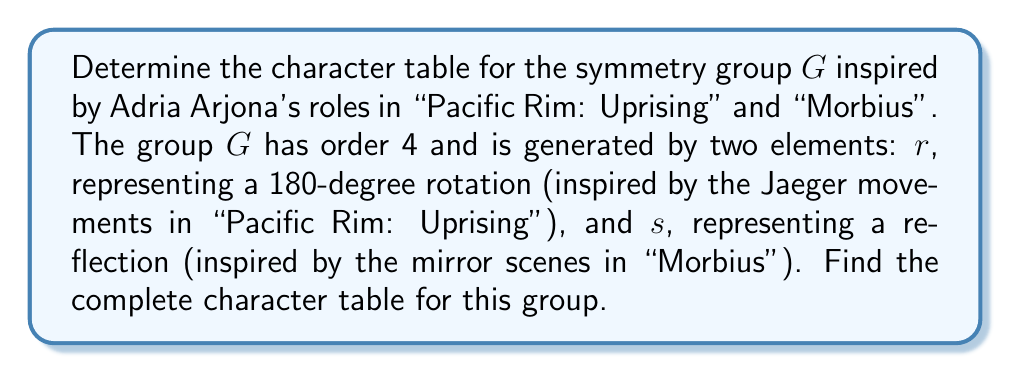Could you help me with this problem? To determine the character table for the symmetry group $G$, we'll follow these steps:

1) First, identify the elements of the group:
   $G = \{e, r, s, rs\}$, where $e$ is the identity element.

2) Determine the conjugacy classes:
   - $\{e\}$ (identity always forms its own class)
   - $\{r\}$ (rotation by 180 degrees)
   - $\{s, rs\}$ (reflections)

3) The number of irreducible representations equals the number of conjugacy classes, so we have 3 irreducible representations.

4) The dimensions of these representations must satisfy:
   $1^2 + 1^2 + 1^2 = 4$ (order of the group)
   So, all representations are 1-dimensional.

5) Let's call these representations $\chi_1, \chi_2, \chi_3$.

6) $\chi_1$ is always the trivial representation, sending every element to 1.

7) For $\chi_2$:
   - $\chi_2(e) = 1$ (always for 1D representations)
   - $\chi_2(r) = 1$ (as $r^2 = e$)
   - $\chi_2(s) = -1$ (as $s^2 = e$, but $s \neq e$)

8) For $\chi_3$:
   - $\chi_3(e) = 1$
   - $\chi_3(r) = -1$ (to ensure orthogonality with $\chi_2$)
   - $\chi_3(s) = -1$ (to ensure $\chi_3(rs) = \chi_3(r)\chi_3(s) = 1$)

9) Construct the character table:

$$
\begin{array}{c|ccc}
G & \{e\} & \{r\} & \{s, rs\} \\
\hline
\chi_1 & 1 & 1 & 1 \\
\chi_2 & 1 & 1 & -1 \\
\chi_3 & 1 & -1 & -1
\end{array}
$$

This completes the character table for the symmetry group $G$.
Answer: $$
\begin{array}{c|ccc}
G & \{e\} & \{r\} & \{s, rs\} \\
\hline
\chi_1 & 1 & 1 & 1 \\
\chi_2 & 1 & 1 & -1 \\
\chi_3 & 1 & -1 & -1
\end{array}
$$ 